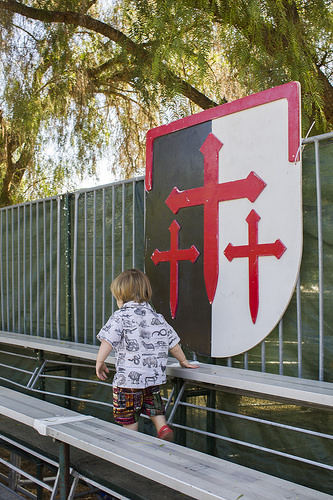<image>
Can you confirm if the sign is in front of the kid? No. The sign is not in front of the kid. The spatial positioning shows a different relationship between these objects. 